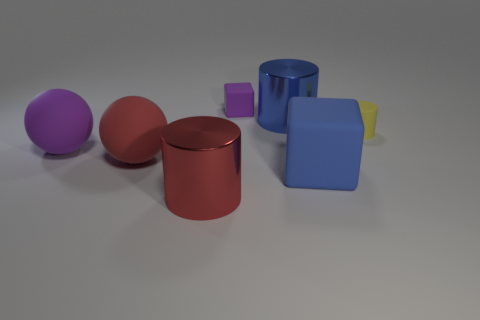The small purple object is what shape?
Ensure brevity in your answer.  Cube. What number of small objects are either purple matte things or yellow matte cylinders?
Your answer should be very brief. 2. What size is the yellow thing that is the same shape as the large blue metal object?
Make the answer very short. Small. How many matte objects are behind the large blue rubber thing and in front of the yellow matte cylinder?
Your answer should be compact. 2. There is a tiny purple object; is its shape the same as the tiny matte object in front of the blue cylinder?
Offer a terse response. No. Are there more large red shiny things that are right of the red cylinder than small blue rubber objects?
Offer a very short reply. No. Are there fewer small yellow matte cylinders in front of the red cylinder than red matte spheres?
Provide a short and direct response. Yes. How many matte spheres have the same color as the tiny rubber block?
Make the answer very short. 1. There is a thing that is in front of the yellow cylinder and to the right of the blue shiny thing; what is its material?
Your response must be concise. Rubber. There is a matte block in front of the purple rubber block; is it the same color as the shiny object that is to the right of the tiny block?
Your answer should be very brief. Yes. 